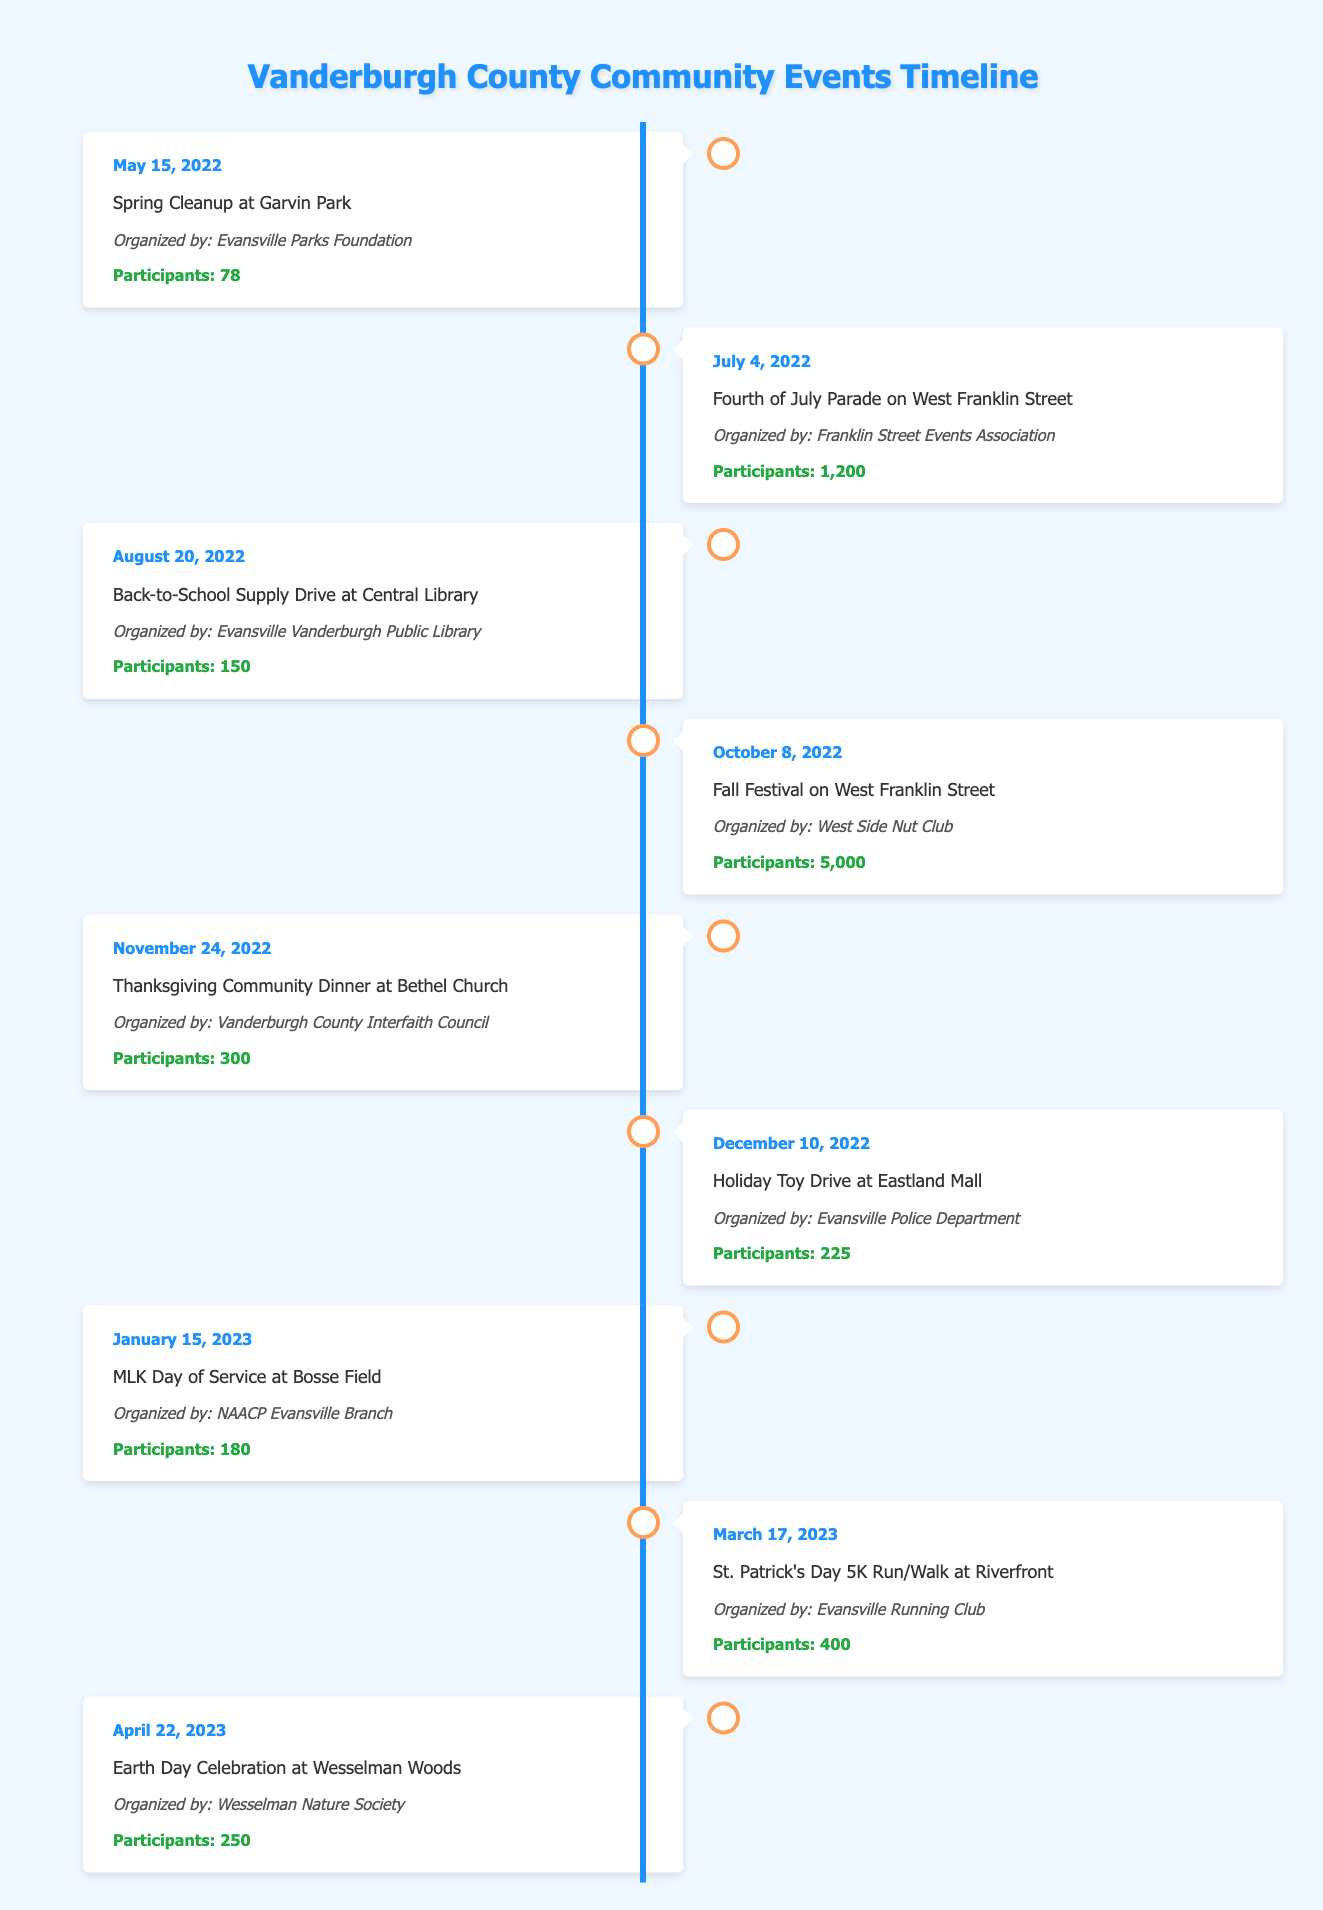What was the largest community event by participant count? The largest community event was the Fall Festival on West Franklin Street with 5,000 participants. This information is found by comparing the participant counts from the events listed in the table.
Answer: 5,000 How many total participants attended events in 2022? To find the total participants in 2022, I summed the participants for each event that year: 78 (Spring Cleanup) + 1200 (Fourth of July Parade) + 150 (Back-to-School Supply Drive) + 5000 (Fall Festival) + 300 (Thanksgiving Dinner) + 225 (Holiday Toy Drive) = 6,953 participants.
Answer: 6,953 Did any event have more than 400 participants? Yes, the Fall Festival on West Franklin Street, the Fourth of July Parade, and the Thanksgiving Community Dinner all had more than 400 participants. We can verify this by checking each event's participant count in the table.
Answer: Yes Which organizer had the most events listed in the table? The West Side Nut Club organized the Fall Festival, while the other events were organized by different entities. Each organizer is listed in the table, and I counted one event for each listed organizer. No organizer appears more than once in this dataset.
Answer: None What was the average number of participants across all events listed? To find the average number of participants, I summed the participants: 78 + 1200 + 150 + 5000 + 300 + 225 + 180 + 400 + 250 = 6,583. There are 9 events in total, so to find the average: 6,583 / 9 = 731.44 participants.
Answer: 731.44 Which event was organized on January 15, 2023? The event organized on January 15, 2023, was the MLK Day of Service at Bosse Field. The date can be directly referenced in the date column of the table.
Answer: MLK Day of Service at Bosse Field How many events were organized by the Evansville Parks Foundation? The Evansville Parks Foundation organized one event, the Spring Cleanup at Garvin Park. I can find this by locating the organizer's name in the table.
Answer: One Was there an event focused on environmental awareness? Yes, the Earth Day Celebration at Wesselman Woods is focused on environmental awareness, as indicated by the event name. This determination comes directly from the event descriptions in the table.
Answer: Yes What is the gap in months between the Fourth of July Parade and the Holiday Toy Drive? The Fourth of July Parade took place on July 4, 2022, and the Holiday Toy Drive was on December 10, 2022. The months between these dates are July, August, September, October, November, and December, totaling 5 months.
Answer: 5 months 